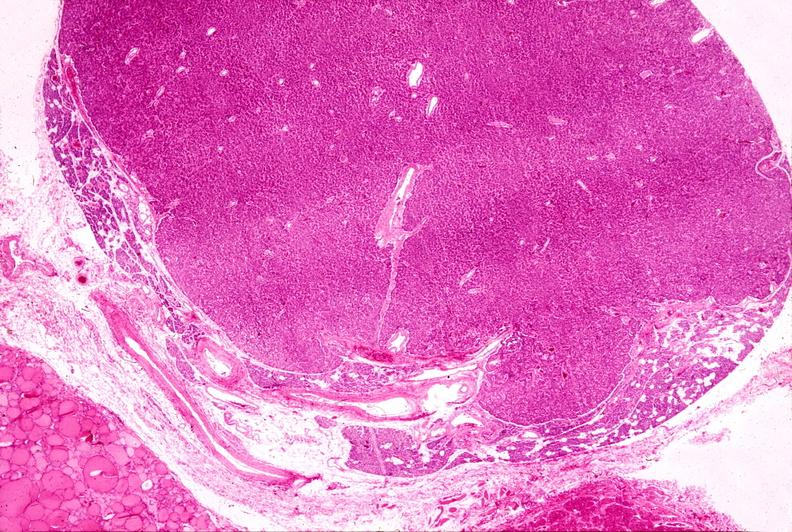does this image show parathyroid adenoma, h & e low mag?
Answer the question using a single word or phrase. Yes 